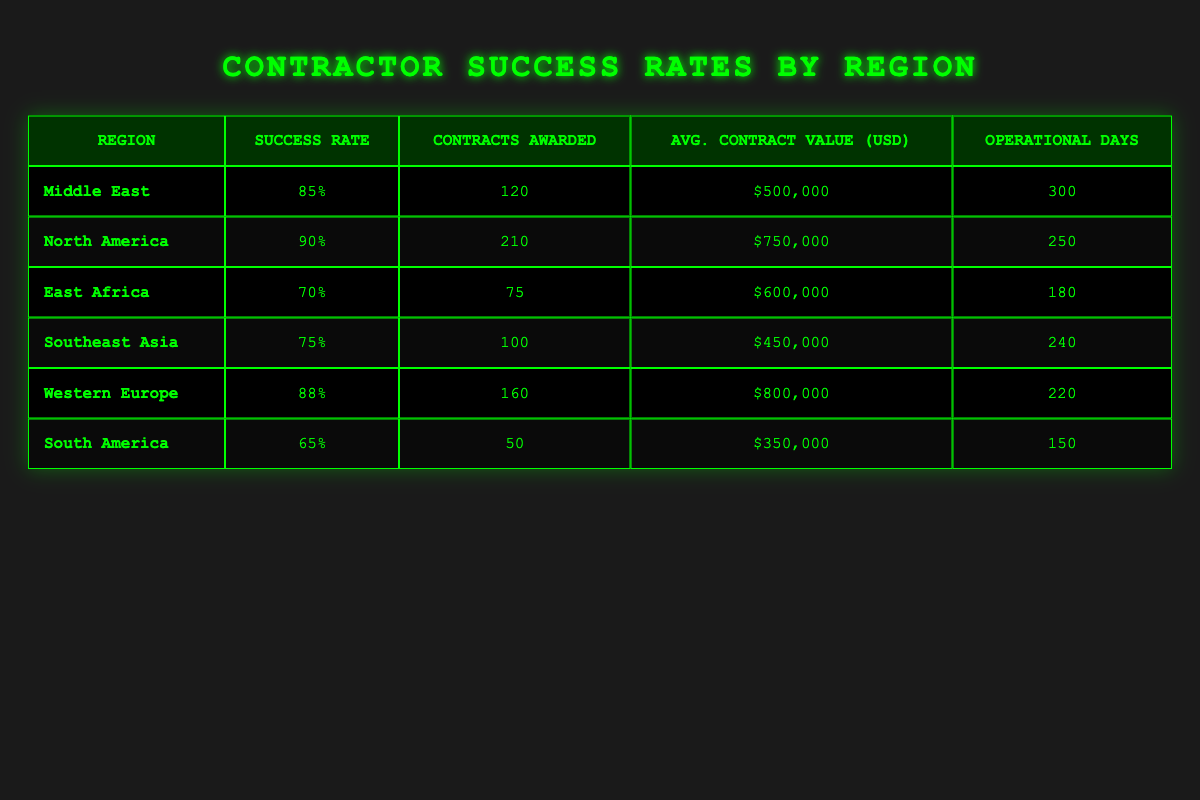What is the success rate in North America? The success rate for North America is directly stated in the table under the "Success Rate" column for that region. It reads 90%.
Answer: 90% Which region has the highest average contract value? The average contract values are provided for each region. By examining the "Avg. Contract Value (USD)" column, we find that Western Europe has the highest value of $800,000.
Answer: Western Europe Is the success rate in South America above 70%? The success rate for South America is provided in the table, which shows a success rate of 65%. Since 65% is not above 70%, the answer is no.
Answer: No What is the difference in success rates between North America and Southeast Asia? To find the difference, we subtract the success rate of Southeast Asia (75%) from that of North America (90%). This calculation gives us 90 - 75 = 15.
Answer: 15 How many total contracts were awarded in the Middle East and East Africa combined? We add the number of contracts awarded in both regions: Middle East (120) and East Africa (75). The total is 120 + 75 = 195.
Answer: 195 Which region has the longest operational days and how many are there? The operational days are listed for each region. By checking the "Operational Days" column, we see that the Middle East has the longest operational days with a count of 300 days.
Answer: Middle East, 300 What is the average success rate across all regions? To find the average, we add all success rates together: 85 + 90 + 70 + 75 + 88 + 65 = 473. Then, we divide by the number of regions (6): 473 / 6 ≈ 78.83.
Answer: 78.83 Does Western Europe have a higher success rate than Southeast Asia? The success rate for Western Europe is 88%, and for Southeast Asia, it is 75%. Since 88% is greater than 75%, the answer is yes.
Answer: Yes What percentage of contracts awarded in Southeast Asia are above 80% success rate? Given that only Southeast Asia has a success rate below 80% at 75%, the percentage of contracts above this rate is 0%.
Answer: 0% 